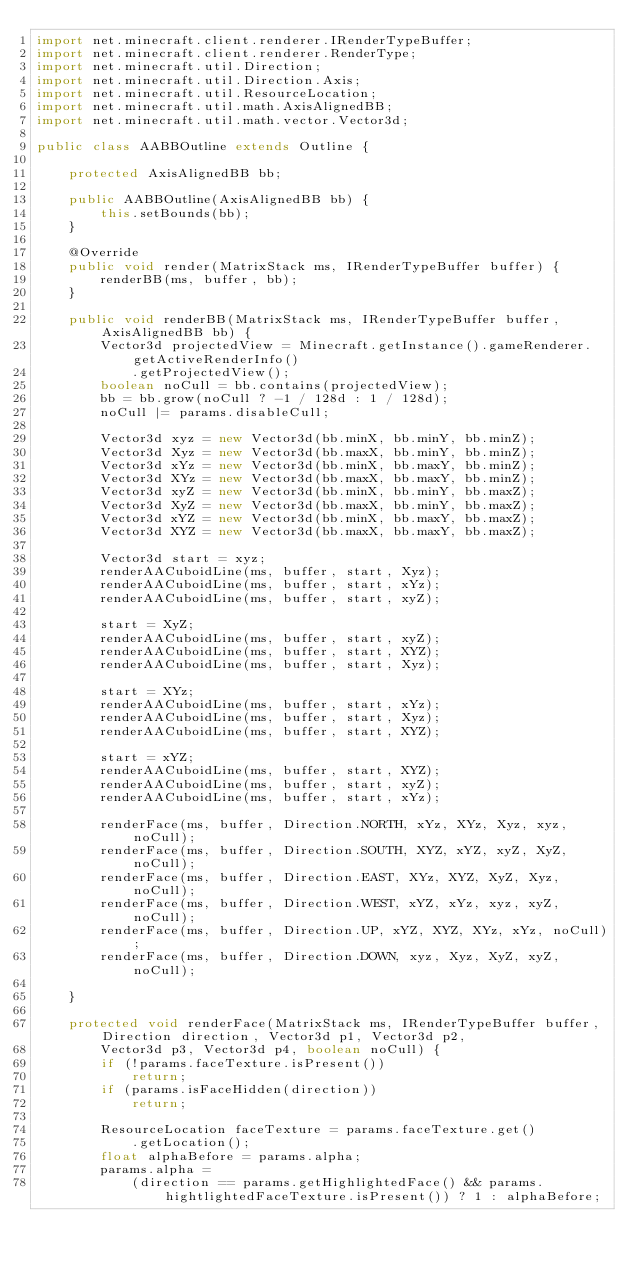<code> <loc_0><loc_0><loc_500><loc_500><_Java_>import net.minecraft.client.renderer.IRenderTypeBuffer;
import net.minecraft.client.renderer.RenderType;
import net.minecraft.util.Direction;
import net.minecraft.util.Direction.Axis;
import net.minecraft.util.ResourceLocation;
import net.minecraft.util.math.AxisAlignedBB;
import net.minecraft.util.math.vector.Vector3d;

public class AABBOutline extends Outline {

	protected AxisAlignedBB bb;

	public AABBOutline(AxisAlignedBB bb) {
		this.setBounds(bb);
	}

	@Override
	public void render(MatrixStack ms, IRenderTypeBuffer buffer) {
		renderBB(ms, buffer, bb);
	}

	public void renderBB(MatrixStack ms, IRenderTypeBuffer buffer, AxisAlignedBB bb) {
		Vector3d projectedView = Minecraft.getInstance().gameRenderer.getActiveRenderInfo()
			.getProjectedView();
		boolean noCull = bb.contains(projectedView);
		bb = bb.grow(noCull ? -1 / 128d : 1 / 128d);
		noCull |= params.disableCull;

		Vector3d xyz = new Vector3d(bb.minX, bb.minY, bb.minZ);
		Vector3d Xyz = new Vector3d(bb.maxX, bb.minY, bb.minZ);
		Vector3d xYz = new Vector3d(bb.minX, bb.maxY, bb.minZ);
		Vector3d XYz = new Vector3d(bb.maxX, bb.maxY, bb.minZ);
		Vector3d xyZ = new Vector3d(bb.minX, bb.minY, bb.maxZ);
		Vector3d XyZ = new Vector3d(bb.maxX, bb.minY, bb.maxZ);
		Vector3d xYZ = new Vector3d(bb.minX, bb.maxY, bb.maxZ);
		Vector3d XYZ = new Vector3d(bb.maxX, bb.maxY, bb.maxZ);

		Vector3d start = xyz;
		renderAACuboidLine(ms, buffer, start, Xyz);
		renderAACuboidLine(ms, buffer, start, xYz);
		renderAACuboidLine(ms, buffer, start, xyZ);

		start = XyZ;
		renderAACuboidLine(ms, buffer, start, xyZ);
		renderAACuboidLine(ms, buffer, start, XYZ);
		renderAACuboidLine(ms, buffer, start, Xyz);

		start = XYz;
		renderAACuboidLine(ms, buffer, start, xYz);
		renderAACuboidLine(ms, buffer, start, Xyz);
		renderAACuboidLine(ms, buffer, start, XYZ);

		start = xYZ;
		renderAACuboidLine(ms, buffer, start, XYZ);
		renderAACuboidLine(ms, buffer, start, xyZ);
		renderAACuboidLine(ms, buffer, start, xYz);

		renderFace(ms, buffer, Direction.NORTH, xYz, XYz, Xyz, xyz, noCull);
		renderFace(ms, buffer, Direction.SOUTH, XYZ, xYZ, xyZ, XyZ, noCull);
		renderFace(ms, buffer, Direction.EAST, XYz, XYZ, XyZ, Xyz, noCull);
		renderFace(ms, buffer, Direction.WEST, xYZ, xYz, xyz, xyZ, noCull);
		renderFace(ms, buffer, Direction.UP, xYZ, XYZ, XYz, xYz, noCull);
		renderFace(ms, buffer, Direction.DOWN, xyz, Xyz, XyZ, xyZ, noCull);

	}

	protected void renderFace(MatrixStack ms, IRenderTypeBuffer buffer, Direction direction, Vector3d p1, Vector3d p2,
		Vector3d p3, Vector3d p4, boolean noCull) {
		if (!params.faceTexture.isPresent())
			return;
		if (params.isFaceHidden(direction))
			return;

		ResourceLocation faceTexture = params.faceTexture.get()
			.getLocation();
		float alphaBefore = params.alpha;
		params.alpha =
			(direction == params.getHighlightedFace() && params.hightlightedFaceTexture.isPresent()) ? 1 : alphaBefore;
</code> 